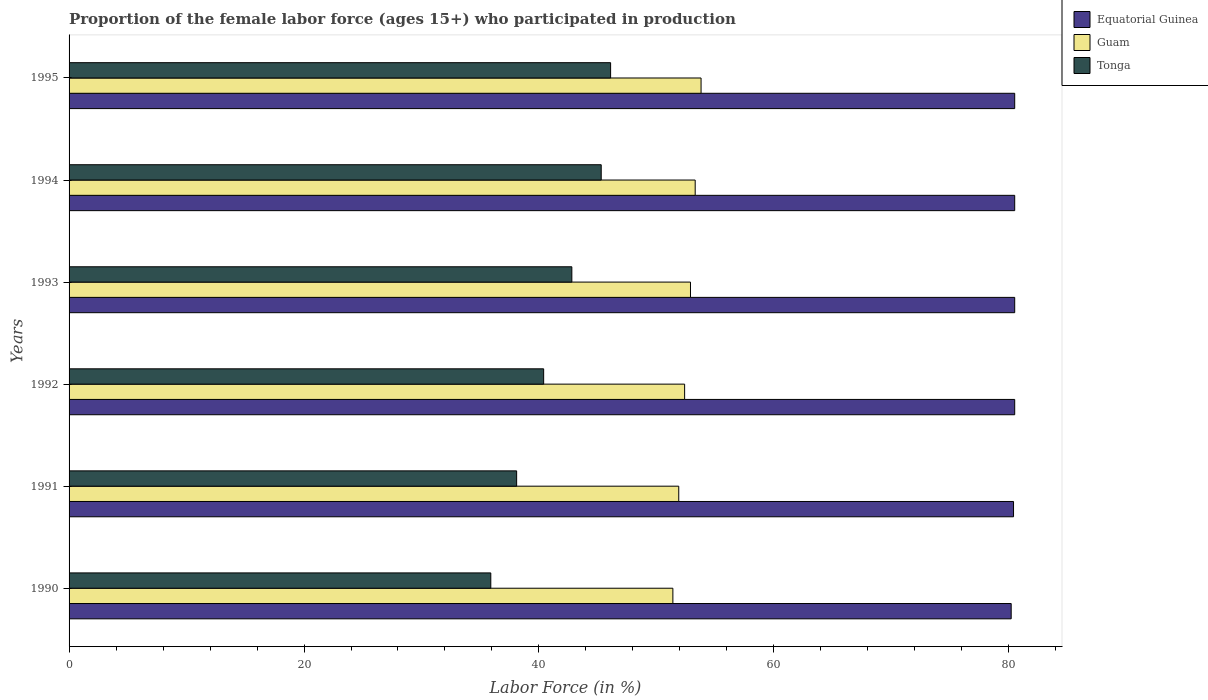How many different coloured bars are there?
Offer a terse response. 3. How many groups of bars are there?
Provide a short and direct response. 6. Are the number of bars per tick equal to the number of legend labels?
Give a very brief answer. Yes. Are the number of bars on each tick of the Y-axis equal?
Your answer should be very brief. Yes. How many bars are there on the 3rd tick from the top?
Your answer should be very brief. 3. In how many cases, is the number of bars for a given year not equal to the number of legend labels?
Provide a short and direct response. 0. What is the proportion of the female labor force who participated in production in Tonga in 1994?
Provide a succinct answer. 45.3. Across all years, what is the maximum proportion of the female labor force who participated in production in Equatorial Guinea?
Provide a short and direct response. 80.5. Across all years, what is the minimum proportion of the female labor force who participated in production in Tonga?
Provide a succinct answer. 35.9. In which year was the proportion of the female labor force who participated in production in Equatorial Guinea maximum?
Make the answer very short. 1992. What is the total proportion of the female labor force who participated in production in Guam in the graph?
Provide a succinct answer. 315.7. What is the difference between the proportion of the female labor force who participated in production in Tonga in 1991 and that in 1993?
Your answer should be very brief. -4.7. What is the difference between the proportion of the female labor force who participated in production in Equatorial Guinea in 1993 and the proportion of the female labor force who participated in production in Guam in 1992?
Make the answer very short. 28.1. What is the average proportion of the female labor force who participated in production in Equatorial Guinea per year?
Make the answer very short. 80.43. In the year 1991, what is the difference between the proportion of the female labor force who participated in production in Guam and proportion of the female labor force who participated in production in Equatorial Guinea?
Your answer should be very brief. -28.5. What is the ratio of the proportion of the female labor force who participated in production in Guam in 1992 to that in 1993?
Provide a succinct answer. 0.99. Is the difference between the proportion of the female labor force who participated in production in Guam in 1990 and 1994 greater than the difference between the proportion of the female labor force who participated in production in Equatorial Guinea in 1990 and 1994?
Offer a terse response. No. What is the difference between the highest and the second highest proportion of the female labor force who participated in production in Guam?
Ensure brevity in your answer.  0.5. What is the difference between the highest and the lowest proportion of the female labor force who participated in production in Guam?
Ensure brevity in your answer.  2.4. In how many years, is the proportion of the female labor force who participated in production in Tonga greater than the average proportion of the female labor force who participated in production in Tonga taken over all years?
Your answer should be very brief. 3. What does the 3rd bar from the top in 1990 represents?
Make the answer very short. Equatorial Guinea. What does the 1st bar from the bottom in 1990 represents?
Your response must be concise. Equatorial Guinea. What is the difference between two consecutive major ticks on the X-axis?
Provide a short and direct response. 20. Where does the legend appear in the graph?
Provide a succinct answer. Top right. What is the title of the graph?
Make the answer very short. Proportion of the female labor force (ages 15+) who participated in production. Does "Guam" appear as one of the legend labels in the graph?
Provide a succinct answer. Yes. What is the Labor Force (in %) in Equatorial Guinea in 1990?
Your answer should be very brief. 80.2. What is the Labor Force (in %) of Guam in 1990?
Offer a very short reply. 51.4. What is the Labor Force (in %) of Tonga in 1990?
Offer a terse response. 35.9. What is the Labor Force (in %) of Equatorial Guinea in 1991?
Make the answer very short. 80.4. What is the Labor Force (in %) in Guam in 1991?
Provide a succinct answer. 51.9. What is the Labor Force (in %) in Tonga in 1991?
Ensure brevity in your answer.  38.1. What is the Labor Force (in %) in Equatorial Guinea in 1992?
Your answer should be compact. 80.5. What is the Labor Force (in %) of Guam in 1992?
Offer a terse response. 52.4. What is the Labor Force (in %) of Tonga in 1992?
Offer a very short reply. 40.4. What is the Labor Force (in %) in Equatorial Guinea in 1993?
Make the answer very short. 80.5. What is the Labor Force (in %) of Guam in 1993?
Offer a very short reply. 52.9. What is the Labor Force (in %) in Tonga in 1993?
Your answer should be very brief. 42.8. What is the Labor Force (in %) of Equatorial Guinea in 1994?
Make the answer very short. 80.5. What is the Labor Force (in %) of Guam in 1994?
Your response must be concise. 53.3. What is the Labor Force (in %) in Tonga in 1994?
Your response must be concise. 45.3. What is the Labor Force (in %) in Equatorial Guinea in 1995?
Provide a short and direct response. 80.5. What is the Labor Force (in %) of Guam in 1995?
Make the answer very short. 53.8. What is the Labor Force (in %) of Tonga in 1995?
Give a very brief answer. 46.1. Across all years, what is the maximum Labor Force (in %) in Equatorial Guinea?
Your answer should be compact. 80.5. Across all years, what is the maximum Labor Force (in %) of Guam?
Your answer should be compact. 53.8. Across all years, what is the maximum Labor Force (in %) in Tonga?
Provide a short and direct response. 46.1. Across all years, what is the minimum Labor Force (in %) of Equatorial Guinea?
Keep it short and to the point. 80.2. Across all years, what is the minimum Labor Force (in %) in Guam?
Your response must be concise. 51.4. Across all years, what is the minimum Labor Force (in %) of Tonga?
Offer a terse response. 35.9. What is the total Labor Force (in %) of Equatorial Guinea in the graph?
Your answer should be compact. 482.6. What is the total Labor Force (in %) in Guam in the graph?
Offer a terse response. 315.7. What is the total Labor Force (in %) in Tonga in the graph?
Provide a succinct answer. 248.6. What is the difference between the Labor Force (in %) in Equatorial Guinea in 1990 and that in 1991?
Your response must be concise. -0.2. What is the difference between the Labor Force (in %) in Tonga in 1990 and that in 1991?
Offer a very short reply. -2.2. What is the difference between the Labor Force (in %) in Equatorial Guinea in 1990 and that in 1992?
Make the answer very short. -0.3. What is the difference between the Labor Force (in %) of Tonga in 1990 and that in 1992?
Provide a succinct answer. -4.5. What is the difference between the Labor Force (in %) in Tonga in 1990 and that in 1993?
Keep it short and to the point. -6.9. What is the difference between the Labor Force (in %) of Equatorial Guinea in 1990 and that in 1994?
Your answer should be compact. -0.3. What is the difference between the Labor Force (in %) in Tonga in 1990 and that in 1994?
Your response must be concise. -9.4. What is the difference between the Labor Force (in %) in Equatorial Guinea in 1990 and that in 1995?
Ensure brevity in your answer.  -0.3. What is the difference between the Labor Force (in %) in Tonga in 1990 and that in 1995?
Give a very brief answer. -10.2. What is the difference between the Labor Force (in %) of Equatorial Guinea in 1991 and that in 1992?
Give a very brief answer. -0.1. What is the difference between the Labor Force (in %) in Guam in 1991 and that in 1992?
Your answer should be compact. -0.5. What is the difference between the Labor Force (in %) of Tonga in 1991 and that in 1992?
Your answer should be very brief. -2.3. What is the difference between the Labor Force (in %) in Equatorial Guinea in 1991 and that in 1994?
Ensure brevity in your answer.  -0.1. What is the difference between the Labor Force (in %) in Guam in 1991 and that in 1994?
Ensure brevity in your answer.  -1.4. What is the difference between the Labor Force (in %) of Tonga in 1991 and that in 1994?
Make the answer very short. -7.2. What is the difference between the Labor Force (in %) of Tonga in 1991 and that in 1995?
Offer a very short reply. -8. What is the difference between the Labor Force (in %) of Guam in 1992 and that in 1993?
Make the answer very short. -0.5. What is the difference between the Labor Force (in %) in Tonga in 1992 and that in 1993?
Your answer should be very brief. -2.4. What is the difference between the Labor Force (in %) of Equatorial Guinea in 1992 and that in 1994?
Your answer should be very brief. 0. What is the difference between the Labor Force (in %) in Tonga in 1992 and that in 1994?
Give a very brief answer. -4.9. What is the difference between the Labor Force (in %) in Equatorial Guinea in 1993 and that in 1994?
Keep it short and to the point. 0. What is the difference between the Labor Force (in %) of Guam in 1993 and that in 1994?
Provide a short and direct response. -0.4. What is the difference between the Labor Force (in %) of Equatorial Guinea in 1993 and that in 1995?
Your answer should be compact. 0. What is the difference between the Labor Force (in %) of Guam in 1993 and that in 1995?
Offer a very short reply. -0.9. What is the difference between the Labor Force (in %) of Equatorial Guinea in 1994 and that in 1995?
Make the answer very short. 0. What is the difference between the Labor Force (in %) in Guam in 1994 and that in 1995?
Your answer should be very brief. -0.5. What is the difference between the Labor Force (in %) of Tonga in 1994 and that in 1995?
Provide a succinct answer. -0.8. What is the difference between the Labor Force (in %) in Equatorial Guinea in 1990 and the Labor Force (in %) in Guam in 1991?
Your answer should be compact. 28.3. What is the difference between the Labor Force (in %) in Equatorial Guinea in 1990 and the Labor Force (in %) in Tonga in 1991?
Your answer should be very brief. 42.1. What is the difference between the Labor Force (in %) of Equatorial Guinea in 1990 and the Labor Force (in %) of Guam in 1992?
Keep it short and to the point. 27.8. What is the difference between the Labor Force (in %) of Equatorial Guinea in 1990 and the Labor Force (in %) of Tonga in 1992?
Offer a very short reply. 39.8. What is the difference between the Labor Force (in %) of Guam in 1990 and the Labor Force (in %) of Tonga in 1992?
Keep it short and to the point. 11. What is the difference between the Labor Force (in %) in Equatorial Guinea in 1990 and the Labor Force (in %) in Guam in 1993?
Offer a very short reply. 27.3. What is the difference between the Labor Force (in %) in Equatorial Guinea in 1990 and the Labor Force (in %) in Tonga in 1993?
Make the answer very short. 37.4. What is the difference between the Labor Force (in %) of Equatorial Guinea in 1990 and the Labor Force (in %) of Guam in 1994?
Make the answer very short. 26.9. What is the difference between the Labor Force (in %) in Equatorial Guinea in 1990 and the Labor Force (in %) in Tonga in 1994?
Give a very brief answer. 34.9. What is the difference between the Labor Force (in %) in Equatorial Guinea in 1990 and the Labor Force (in %) in Guam in 1995?
Your answer should be compact. 26.4. What is the difference between the Labor Force (in %) of Equatorial Guinea in 1990 and the Labor Force (in %) of Tonga in 1995?
Make the answer very short. 34.1. What is the difference between the Labor Force (in %) in Guam in 1991 and the Labor Force (in %) in Tonga in 1992?
Offer a terse response. 11.5. What is the difference between the Labor Force (in %) of Equatorial Guinea in 1991 and the Labor Force (in %) of Guam in 1993?
Keep it short and to the point. 27.5. What is the difference between the Labor Force (in %) in Equatorial Guinea in 1991 and the Labor Force (in %) in Tonga in 1993?
Ensure brevity in your answer.  37.6. What is the difference between the Labor Force (in %) in Equatorial Guinea in 1991 and the Labor Force (in %) in Guam in 1994?
Give a very brief answer. 27.1. What is the difference between the Labor Force (in %) of Equatorial Guinea in 1991 and the Labor Force (in %) of Tonga in 1994?
Offer a very short reply. 35.1. What is the difference between the Labor Force (in %) of Equatorial Guinea in 1991 and the Labor Force (in %) of Guam in 1995?
Your response must be concise. 26.6. What is the difference between the Labor Force (in %) of Equatorial Guinea in 1991 and the Labor Force (in %) of Tonga in 1995?
Ensure brevity in your answer.  34.3. What is the difference between the Labor Force (in %) in Guam in 1991 and the Labor Force (in %) in Tonga in 1995?
Offer a very short reply. 5.8. What is the difference between the Labor Force (in %) of Equatorial Guinea in 1992 and the Labor Force (in %) of Guam in 1993?
Provide a succinct answer. 27.6. What is the difference between the Labor Force (in %) in Equatorial Guinea in 1992 and the Labor Force (in %) in Tonga in 1993?
Your response must be concise. 37.7. What is the difference between the Labor Force (in %) of Equatorial Guinea in 1992 and the Labor Force (in %) of Guam in 1994?
Provide a short and direct response. 27.2. What is the difference between the Labor Force (in %) of Equatorial Guinea in 1992 and the Labor Force (in %) of Tonga in 1994?
Provide a succinct answer. 35.2. What is the difference between the Labor Force (in %) in Equatorial Guinea in 1992 and the Labor Force (in %) in Guam in 1995?
Provide a short and direct response. 26.7. What is the difference between the Labor Force (in %) in Equatorial Guinea in 1992 and the Labor Force (in %) in Tonga in 1995?
Make the answer very short. 34.4. What is the difference between the Labor Force (in %) of Equatorial Guinea in 1993 and the Labor Force (in %) of Guam in 1994?
Provide a short and direct response. 27.2. What is the difference between the Labor Force (in %) in Equatorial Guinea in 1993 and the Labor Force (in %) in Tonga in 1994?
Provide a short and direct response. 35.2. What is the difference between the Labor Force (in %) of Guam in 1993 and the Labor Force (in %) of Tonga in 1994?
Offer a terse response. 7.6. What is the difference between the Labor Force (in %) of Equatorial Guinea in 1993 and the Labor Force (in %) of Guam in 1995?
Give a very brief answer. 26.7. What is the difference between the Labor Force (in %) in Equatorial Guinea in 1993 and the Labor Force (in %) in Tonga in 1995?
Ensure brevity in your answer.  34.4. What is the difference between the Labor Force (in %) of Equatorial Guinea in 1994 and the Labor Force (in %) of Guam in 1995?
Provide a succinct answer. 26.7. What is the difference between the Labor Force (in %) in Equatorial Guinea in 1994 and the Labor Force (in %) in Tonga in 1995?
Provide a short and direct response. 34.4. What is the difference between the Labor Force (in %) in Guam in 1994 and the Labor Force (in %) in Tonga in 1995?
Make the answer very short. 7.2. What is the average Labor Force (in %) of Equatorial Guinea per year?
Your answer should be compact. 80.43. What is the average Labor Force (in %) of Guam per year?
Offer a terse response. 52.62. What is the average Labor Force (in %) of Tonga per year?
Provide a short and direct response. 41.43. In the year 1990, what is the difference between the Labor Force (in %) of Equatorial Guinea and Labor Force (in %) of Guam?
Provide a succinct answer. 28.8. In the year 1990, what is the difference between the Labor Force (in %) of Equatorial Guinea and Labor Force (in %) of Tonga?
Offer a terse response. 44.3. In the year 1991, what is the difference between the Labor Force (in %) in Equatorial Guinea and Labor Force (in %) in Tonga?
Provide a short and direct response. 42.3. In the year 1991, what is the difference between the Labor Force (in %) in Guam and Labor Force (in %) in Tonga?
Give a very brief answer. 13.8. In the year 1992, what is the difference between the Labor Force (in %) in Equatorial Guinea and Labor Force (in %) in Guam?
Make the answer very short. 28.1. In the year 1992, what is the difference between the Labor Force (in %) in Equatorial Guinea and Labor Force (in %) in Tonga?
Give a very brief answer. 40.1. In the year 1992, what is the difference between the Labor Force (in %) in Guam and Labor Force (in %) in Tonga?
Ensure brevity in your answer.  12. In the year 1993, what is the difference between the Labor Force (in %) of Equatorial Guinea and Labor Force (in %) of Guam?
Provide a short and direct response. 27.6. In the year 1993, what is the difference between the Labor Force (in %) in Equatorial Guinea and Labor Force (in %) in Tonga?
Keep it short and to the point. 37.7. In the year 1993, what is the difference between the Labor Force (in %) of Guam and Labor Force (in %) of Tonga?
Offer a very short reply. 10.1. In the year 1994, what is the difference between the Labor Force (in %) in Equatorial Guinea and Labor Force (in %) in Guam?
Your response must be concise. 27.2. In the year 1994, what is the difference between the Labor Force (in %) in Equatorial Guinea and Labor Force (in %) in Tonga?
Ensure brevity in your answer.  35.2. In the year 1995, what is the difference between the Labor Force (in %) in Equatorial Guinea and Labor Force (in %) in Guam?
Your answer should be very brief. 26.7. In the year 1995, what is the difference between the Labor Force (in %) in Equatorial Guinea and Labor Force (in %) in Tonga?
Your answer should be compact. 34.4. In the year 1995, what is the difference between the Labor Force (in %) in Guam and Labor Force (in %) in Tonga?
Ensure brevity in your answer.  7.7. What is the ratio of the Labor Force (in %) of Equatorial Guinea in 1990 to that in 1991?
Ensure brevity in your answer.  1. What is the ratio of the Labor Force (in %) in Tonga in 1990 to that in 1991?
Offer a terse response. 0.94. What is the ratio of the Labor Force (in %) in Equatorial Guinea in 1990 to that in 1992?
Your answer should be very brief. 1. What is the ratio of the Labor Force (in %) of Guam in 1990 to that in 1992?
Provide a succinct answer. 0.98. What is the ratio of the Labor Force (in %) in Tonga in 1990 to that in 1992?
Ensure brevity in your answer.  0.89. What is the ratio of the Labor Force (in %) in Guam in 1990 to that in 1993?
Provide a short and direct response. 0.97. What is the ratio of the Labor Force (in %) in Tonga in 1990 to that in 1993?
Provide a short and direct response. 0.84. What is the ratio of the Labor Force (in %) of Equatorial Guinea in 1990 to that in 1994?
Ensure brevity in your answer.  1. What is the ratio of the Labor Force (in %) of Guam in 1990 to that in 1994?
Offer a terse response. 0.96. What is the ratio of the Labor Force (in %) in Tonga in 1990 to that in 1994?
Provide a short and direct response. 0.79. What is the ratio of the Labor Force (in %) in Equatorial Guinea in 1990 to that in 1995?
Offer a terse response. 1. What is the ratio of the Labor Force (in %) in Guam in 1990 to that in 1995?
Keep it short and to the point. 0.96. What is the ratio of the Labor Force (in %) in Tonga in 1990 to that in 1995?
Make the answer very short. 0.78. What is the ratio of the Labor Force (in %) of Tonga in 1991 to that in 1992?
Your answer should be very brief. 0.94. What is the ratio of the Labor Force (in %) of Guam in 1991 to that in 1993?
Your answer should be compact. 0.98. What is the ratio of the Labor Force (in %) in Tonga in 1991 to that in 1993?
Provide a succinct answer. 0.89. What is the ratio of the Labor Force (in %) of Equatorial Guinea in 1991 to that in 1994?
Offer a very short reply. 1. What is the ratio of the Labor Force (in %) in Guam in 1991 to that in 1994?
Your answer should be very brief. 0.97. What is the ratio of the Labor Force (in %) of Tonga in 1991 to that in 1994?
Offer a terse response. 0.84. What is the ratio of the Labor Force (in %) in Guam in 1991 to that in 1995?
Your answer should be compact. 0.96. What is the ratio of the Labor Force (in %) of Tonga in 1991 to that in 1995?
Make the answer very short. 0.83. What is the ratio of the Labor Force (in %) in Tonga in 1992 to that in 1993?
Ensure brevity in your answer.  0.94. What is the ratio of the Labor Force (in %) in Equatorial Guinea in 1992 to that in 1994?
Ensure brevity in your answer.  1. What is the ratio of the Labor Force (in %) of Guam in 1992 to that in 1994?
Your answer should be very brief. 0.98. What is the ratio of the Labor Force (in %) in Tonga in 1992 to that in 1994?
Offer a very short reply. 0.89. What is the ratio of the Labor Force (in %) of Equatorial Guinea in 1992 to that in 1995?
Ensure brevity in your answer.  1. What is the ratio of the Labor Force (in %) of Tonga in 1992 to that in 1995?
Provide a succinct answer. 0.88. What is the ratio of the Labor Force (in %) of Equatorial Guinea in 1993 to that in 1994?
Your response must be concise. 1. What is the ratio of the Labor Force (in %) of Tonga in 1993 to that in 1994?
Offer a terse response. 0.94. What is the ratio of the Labor Force (in %) of Guam in 1993 to that in 1995?
Make the answer very short. 0.98. What is the ratio of the Labor Force (in %) in Tonga in 1993 to that in 1995?
Offer a very short reply. 0.93. What is the ratio of the Labor Force (in %) in Equatorial Guinea in 1994 to that in 1995?
Offer a very short reply. 1. What is the ratio of the Labor Force (in %) in Guam in 1994 to that in 1995?
Your answer should be compact. 0.99. What is the ratio of the Labor Force (in %) in Tonga in 1994 to that in 1995?
Provide a short and direct response. 0.98. What is the difference between the highest and the second highest Labor Force (in %) in Equatorial Guinea?
Give a very brief answer. 0. What is the difference between the highest and the second highest Labor Force (in %) in Tonga?
Give a very brief answer. 0.8. 